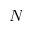Convert formula to latex. <formula><loc_0><loc_0><loc_500><loc_500>N</formula> 